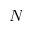Convert formula to latex. <formula><loc_0><loc_0><loc_500><loc_500>N</formula> 